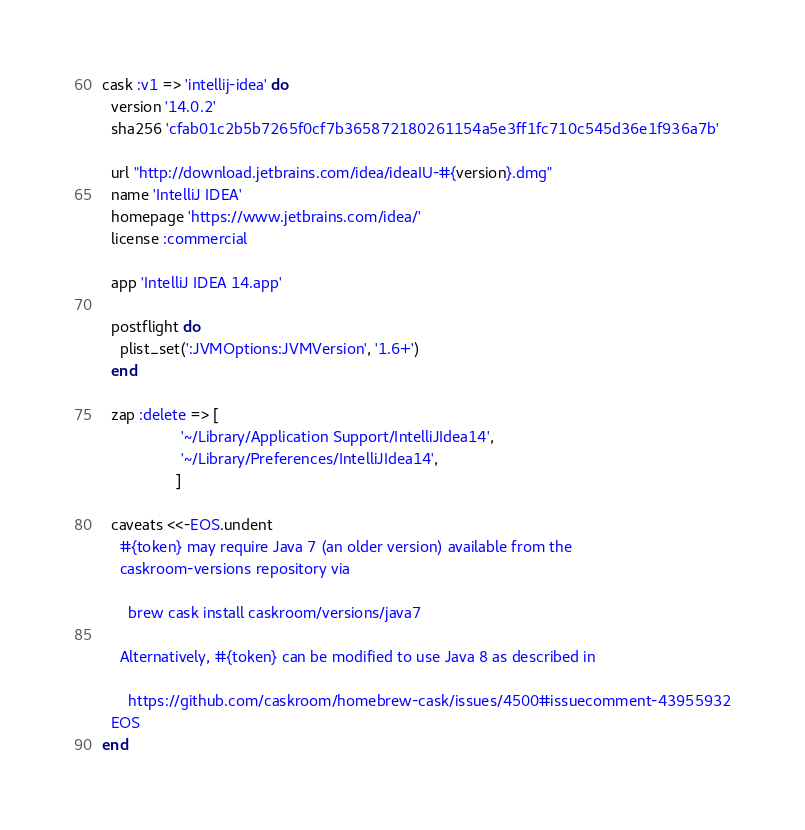<code> <loc_0><loc_0><loc_500><loc_500><_Ruby_>cask :v1 => 'intellij-idea' do
  version '14.0.2'
  sha256 'cfab01c2b5b7265f0cf7b365872180261154a5e3ff1fc710c545d36e1f936a7b'

  url "http://download.jetbrains.com/idea/ideaIU-#{version}.dmg"
  name 'IntelliJ IDEA'
  homepage 'https://www.jetbrains.com/idea/'
  license :commercial

  app 'IntelliJ IDEA 14.app'

  postflight do
    plist_set(':JVMOptions:JVMVersion', '1.6+')
  end

  zap :delete => [
                  '~/Library/Application Support/IntelliJIdea14',
                  '~/Library/Preferences/IntelliJIdea14',
                 ]

  caveats <<-EOS.undent
    #{token} may require Java 7 (an older version) available from the
    caskroom-versions repository via

      brew cask install caskroom/versions/java7

    Alternatively, #{token} can be modified to use Java 8 as described in

      https://github.com/caskroom/homebrew-cask/issues/4500#issuecomment-43955932
  EOS
end
</code> 